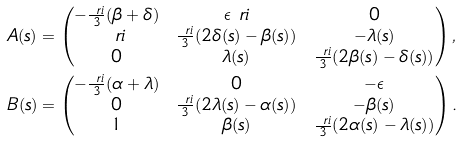<formula> <loc_0><loc_0><loc_500><loc_500>A ( s ) & = \begin{pmatrix} - \frac { \ r i } 3 ( \beta + \delta ) & \epsilon \ r i & 0 \\ \ r i & \frac { \ r i } 3 ( 2 \delta ( s ) - \beta ( s ) ) & - \lambda ( s ) \\ 0 & \lambda ( s ) & \frac { \ r i } 3 ( 2 \beta ( s ) - \delta ( s ) ) \end{pmatrix} , \\ B ( s ) & = \begin{pmatrix} - \frac { \ r i } 3 ( \alpha + \lambda ) & 0 & - \epsilon \\ 0 & \frac { \ r i } 3 ( 2 \lambda ( s ) - \alpha ( s ) ) & - \beta ( s ) \\ 1 & \beta ( s ) & \frac { \ r i } 3 ( 2 \alpha ( s ) - \lambda ( s ) ) \end{pmatrix} .</formula> 